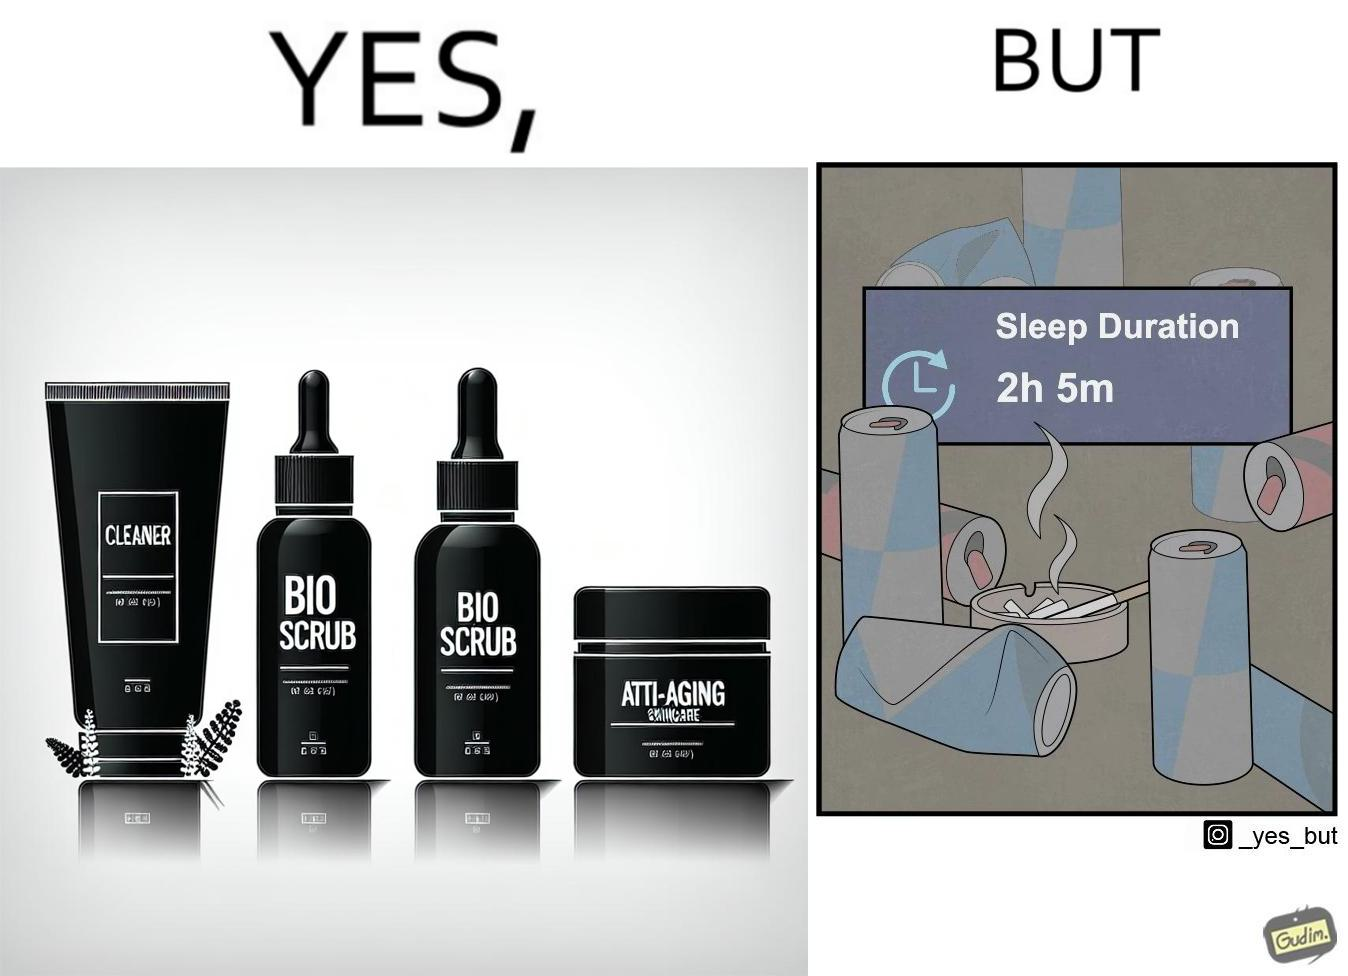Provide a description of this image. This image is ironic as on the one hand, the presumed person is into skincare and wants to do the best for their skin, which is good, but on the other hand, they are involved in unhealthy habits that will damage their skin like smoking, caffeine and inadequate sleep. 